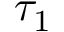Convert formula to latex. <formula><loc_0><loc_0><loc_500><loc_500>\tau _ { 1 }</formula> 